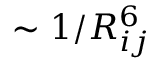<formula> <loc_0><loc_0><loc_500><loc_500>\sim 1 / R _ { i j } ^ { 6 }</formula> 